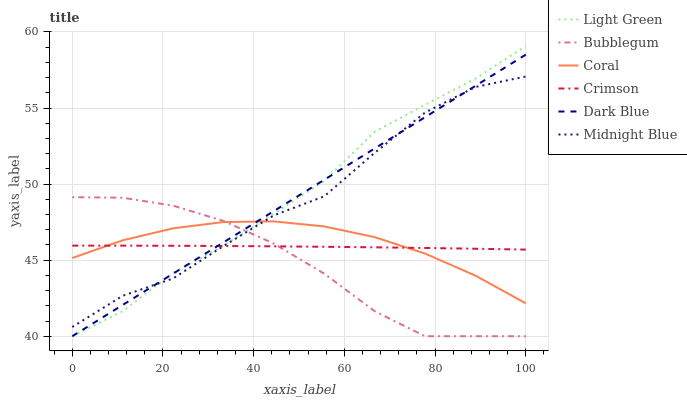Does Bubblegum have the minimum area under the curve?
Answer yes or no. Yes. Does Light Green have the maximum area under the curve?
Answer yes or no. Yes. Does Coral have the minimum area under the curve?
Answer yes or no. No. Does Coral have the maximum area under the curve?
Answer yes or no. No. Is Dark Blue the smoothest?
Answer yes or no. Yes. Is Midnight Blue the roughest?
Answer yes or no. Yes. Is Coral the smoothest?
Answer yes or no. No. Is Coral the roughest?
Answer yes or no. No. Does Bubblegum have the lowest value?
Answer yes or no. Yes. Does Coral have the lowest value?
Answer yes or no. No. Does Light Green have the highest value?
Answer yes or no. Yes. Does Coral have the highest value?
Answer yes or no. No. Does Crimson intersect Coral?
Answer yes or no. Yes. Is Crimson less than Coral?
Answer yes or no. No. Is Crimson greater than Coral?
Answer yes or no. No. 